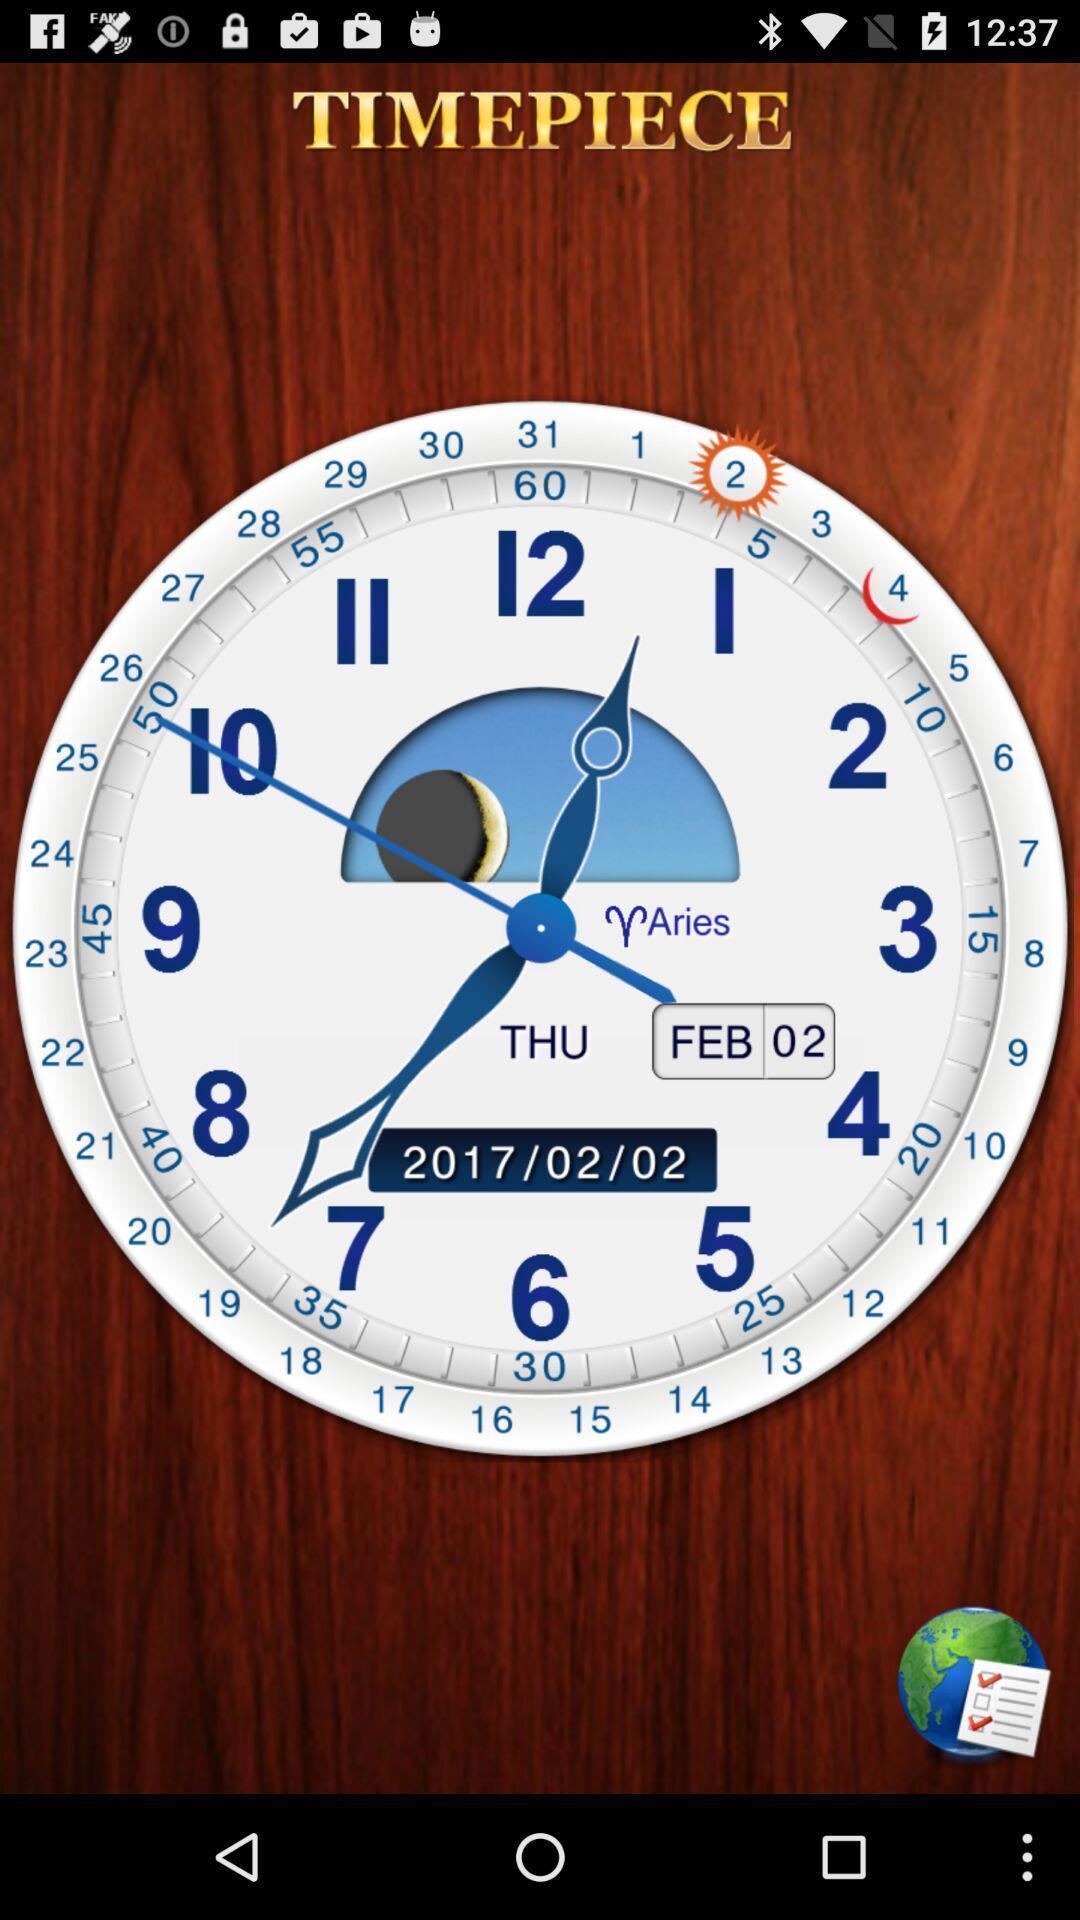What details can you identify in this image? Screen displaying the image of clock with date. 